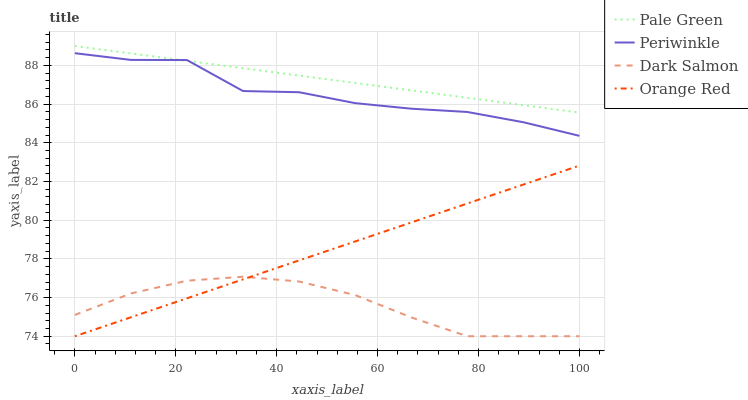Does Dark Salmon have the minimum area under the curve?
Answer yes or no. Yes. Does Pale Green have the maximum area under the curve?
Answer yes or no. Yes. Does Periwinkle have the minimum area under the curve?
Answer yes or no. No. Does Periwinkle have the maximum area under the curve?
Answer yes or no. No. Is Pale Green the smoothest?
Answer yes or no. Yes. Is Periwinkle the roughest?
Answer yes or no. Yes. Is Dark Salmon the smoothest?
Answer yes or no. No. Is Dark Salmon the roughest?
Answer yes or no. No. Does Dark Salmon have the lowest value?
Answer yes or no. Yes. Does Periwinkle have the lowest value?
Answer yes or no. No. Does Pale Green have the highest value?
Answer yes or no. Yes. Does Periwinkle have the highest value?
Answer yes or no. No. Is Orange Red less than Pale Green?
Answer yes or no. Yes. Is Pale Green greater than Orange Red?
Answer yes or no. Yes. Does Orange Red intersect Dark Salmon?
Answer yes or no. Yes. Is Orange Red less than Dark Salmon?
Answer yes or no. No. Is Orange Red greater than Dark Salmon?
Answer yes or no. No. Does Orange Red intersect Pale Green?
Answer yes or no. No. 